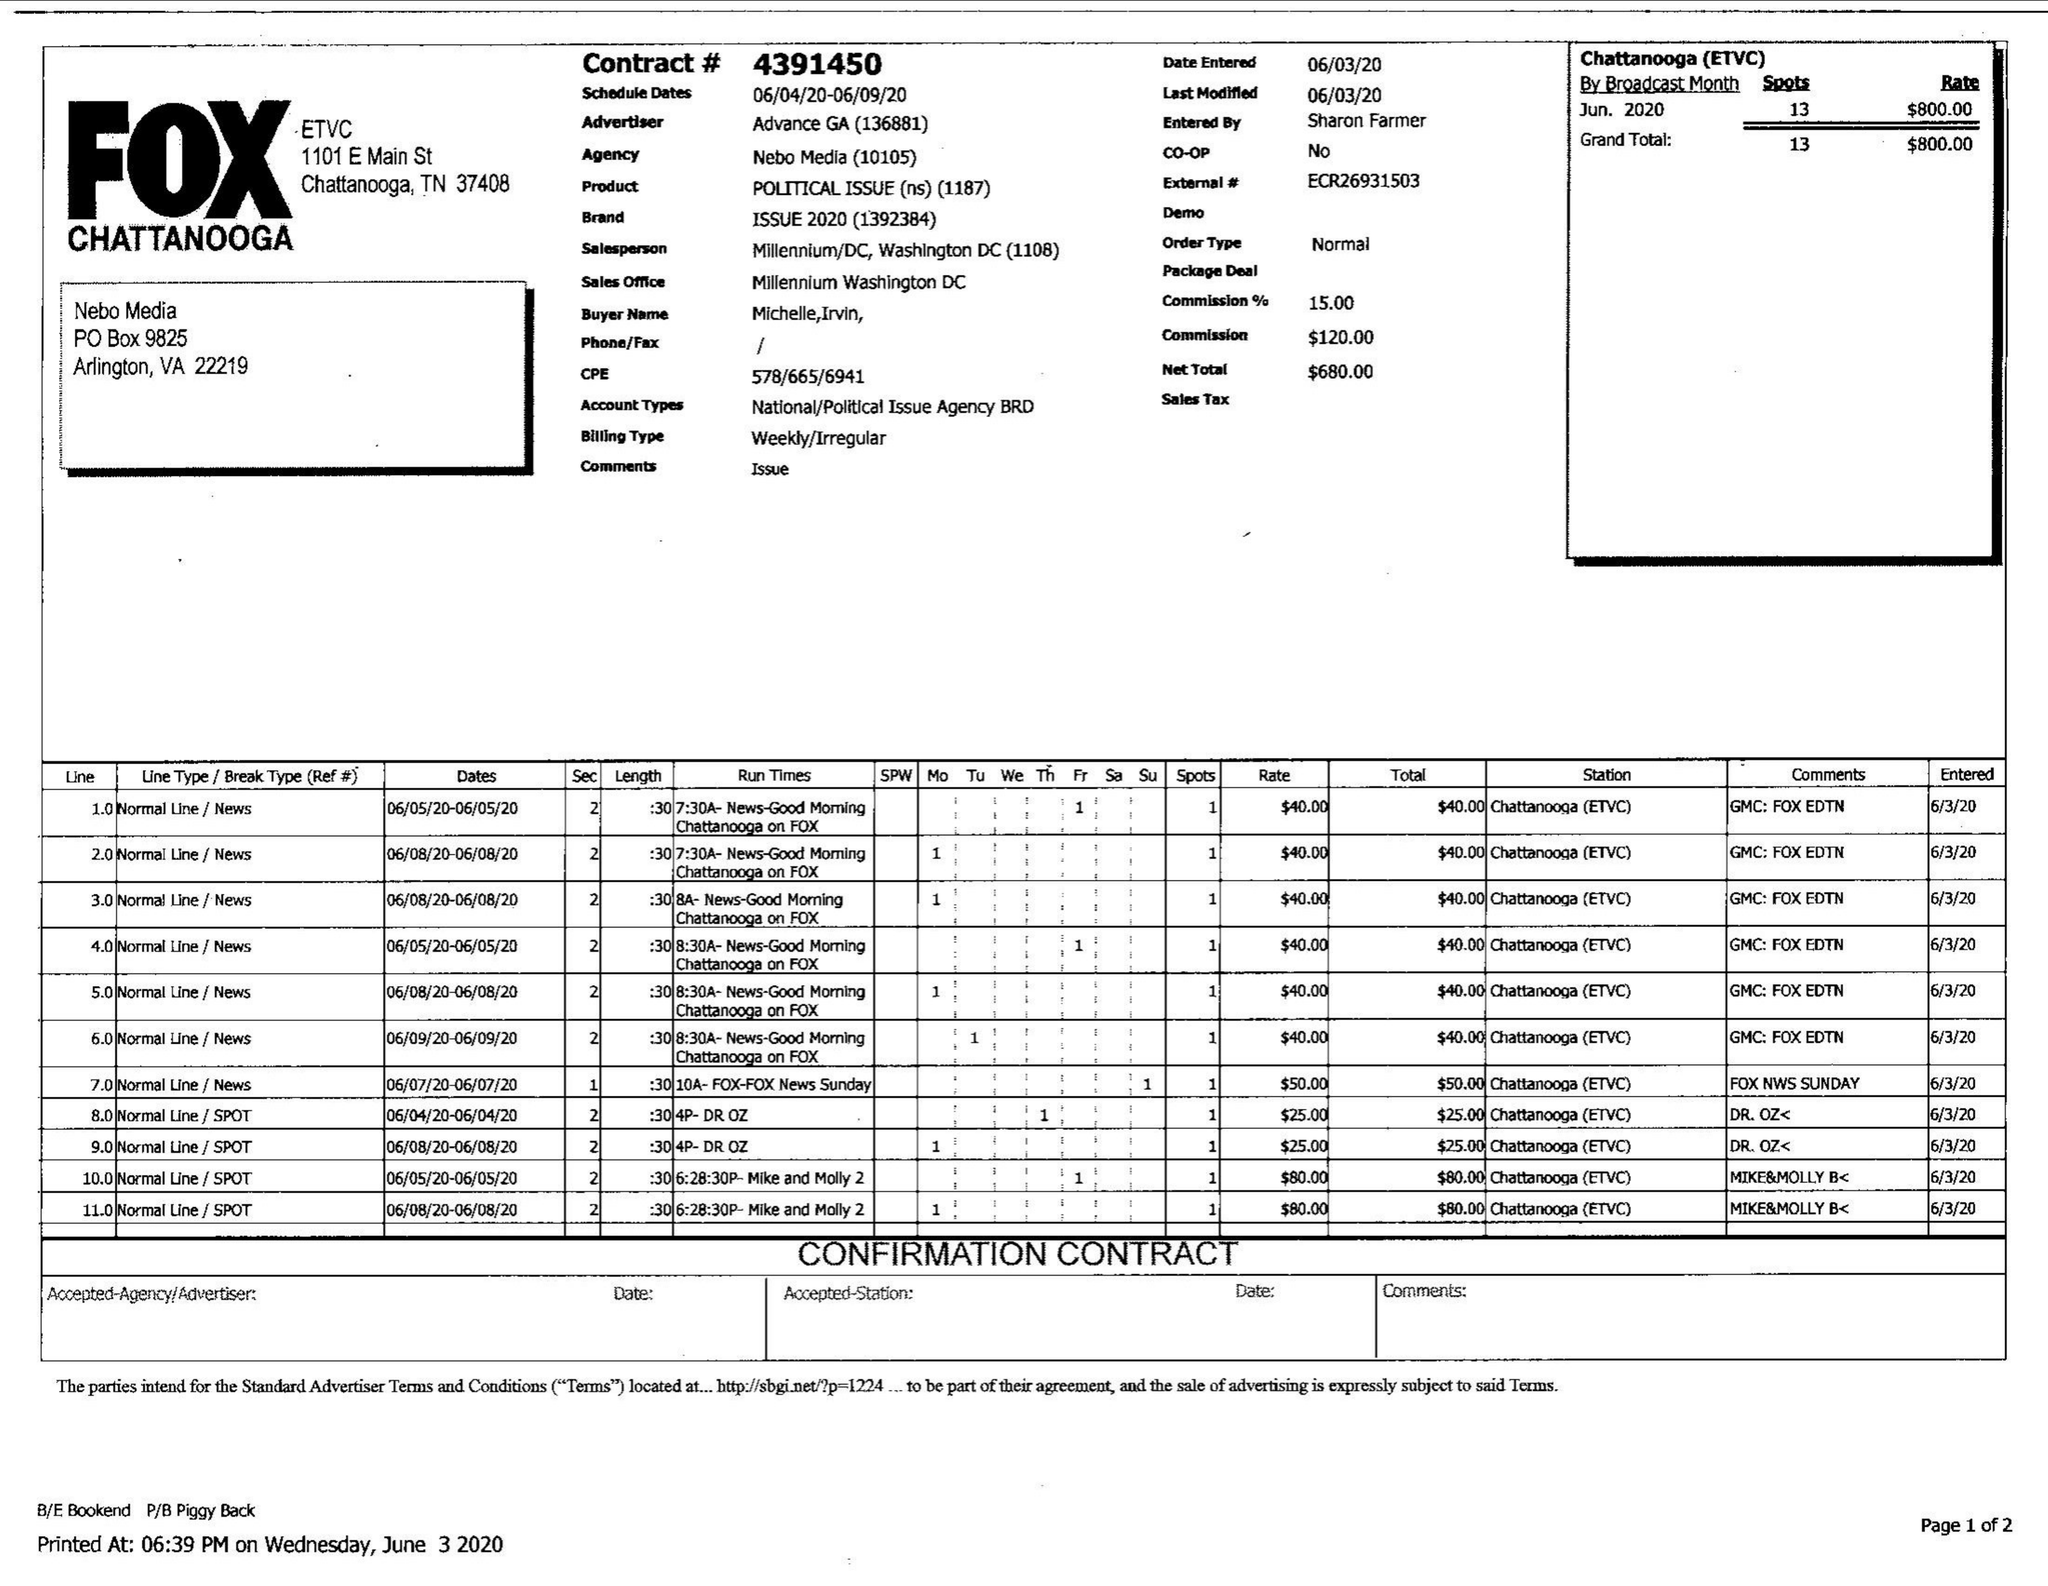What is the value for the advertiser?
Answer the question using a single word or phrase. ADVANCE GA 